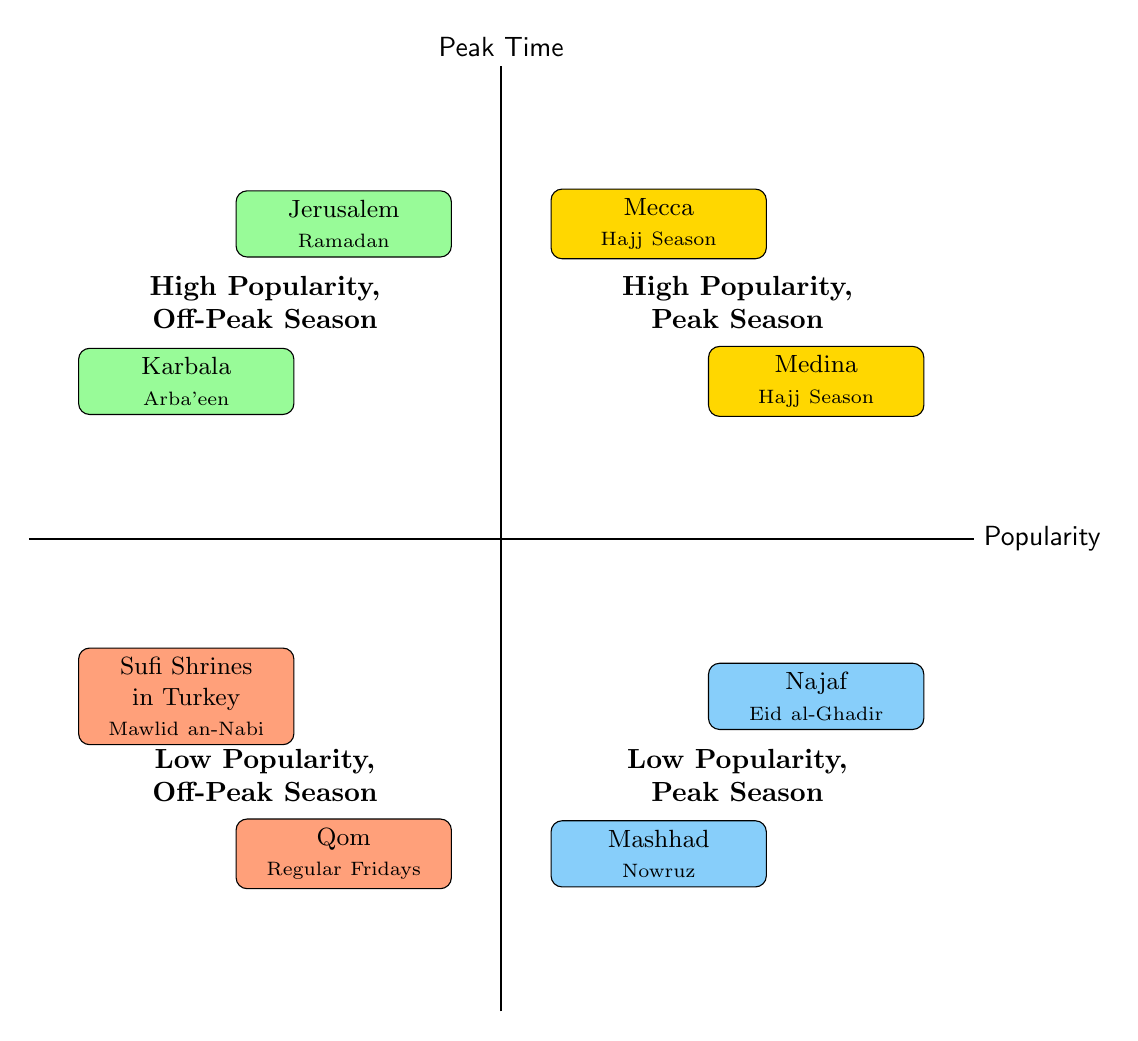What destinations are in the "High Popularity, Peak Season" quadrant? The "High Popularity, Peak Season" quadrant includes Mecca and Medina, as indicated in the diagram.
Answer: Mecca, Medina How many destinations are in the "Low Popularity, Off-Peak Season" quadrant? The "Low Popularity, Off-Peak Season" quadrant contains two destinations: Qom and Sufi Shrines in Turkey. Therefore, there are two destinations in that quadrant.
Answer: 2 What peak time is associated with Jerusalem? In the diagram, Jerusalem is associated with Ramadan. This is visible in the "High Popularity, Off-Peak Season" quadrant.
Answer: Ramadan Which destination has the lowest popularity but is in peak season? The destination with the lowest popularity in the peak season is Mashhad, as shown in the "Low Popularity, Peak Season" quadrant.
Answer: Mashhad What are the peak times for destinations in the "High Popularity, Off-Peak Season" quadrant? The "High Popularity, Off-Peak Season" quadrant includes Jerusalem with Ramadan and Karbala with Arba'een as their respective peak times.
Answer: Ramadan, Arba'een How does the popularity of Medina compare to that of Najaf? Medina is categorized under "High Popularity, Peak Season," while Najaf is under "Low Popularity, Peak Season," indicating that Medina is more popular than Najaf.
Answer: Medina is more popular What is the peak time for Qom? According to the diagram, Qom has a peak time designated as "Regular Fridays." This detail is present in the "Low Popularity, Off-Peak Season" quadrant.
Answer: Regular Fridays Which quadrant has destinations associated with Mawlid an-Nabi? The quadrant that includes destinations associated with Mawlid an-Nabi is "Low Popularity, Off-Peak Season." Here, Sufi Shrines in Turkey is listed with this peak time.
Answer: Low Popularity, Off-Peak Season What is the relationship between the peak times of Mashhad and Najaf? Both Mashhad and Najaf are in the "Low Popularity, Peak Season" quadrant, but they have different peak times: Mashhad during Nowruz and Najaf during Eid al-Ghadir. This means they share the same quadrant but not the same peak time.
Answer: Different peak times 